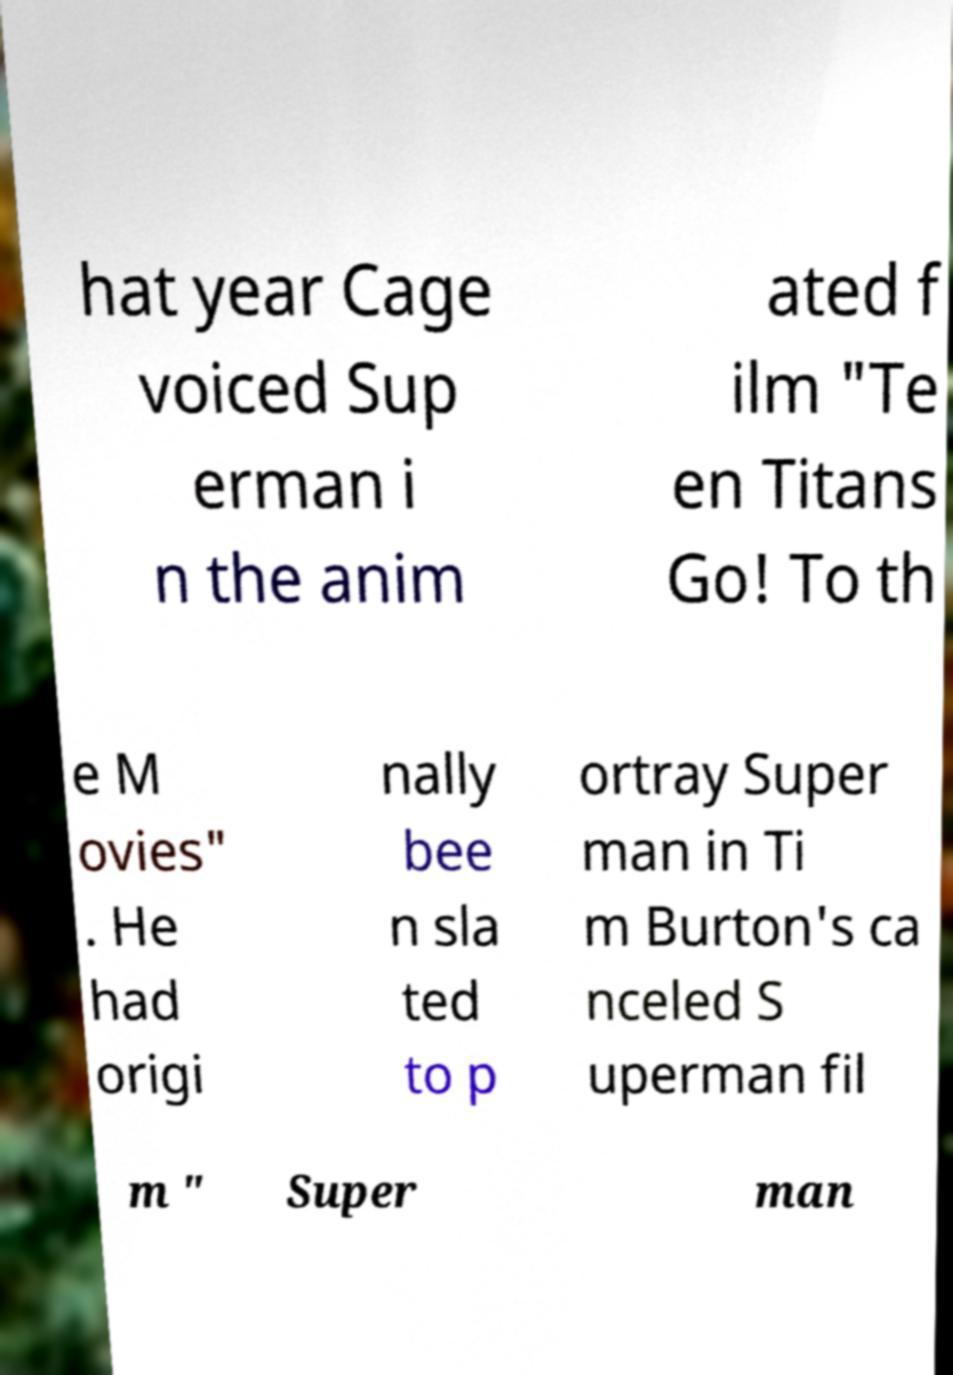I need the written content from this picture converted into text. Can you do that? hat year Cage voiced Sup erman i n the anim ated f ilm "Te en Titans Go! To th e M ovies" . He had origi nally bee n sla ted to p ortray Super man in Ti m Burton's ca nceled S uperman fil m " Super man 